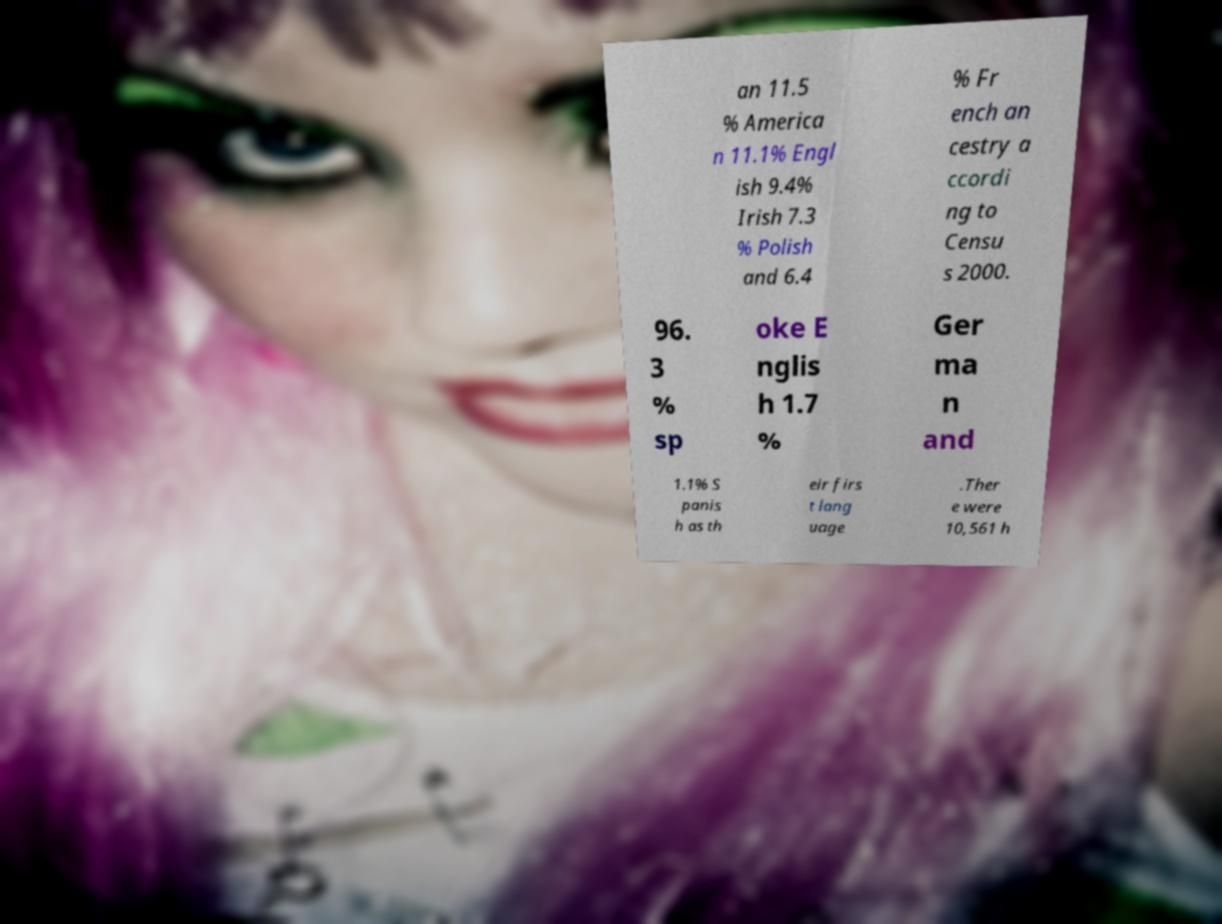Can you accurately transcribe the text from the provided image for me? an 11.5 % America n 11.1% Engl ish 9.4% Irish 7.3 % Polish and 6.4 % Fr ench an cestry a ccordi ng to Censu s 2000. 96. 3 % sp oke E nglis h 1.7 % Ger ma n and 1.1% S panis h as th eir firs t lang uage .Ther e were 10,561 h 